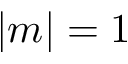Convert formula to latex. <formula><loc_0><loc_0><loc_500><loc_500>| m | = 1</formula> 